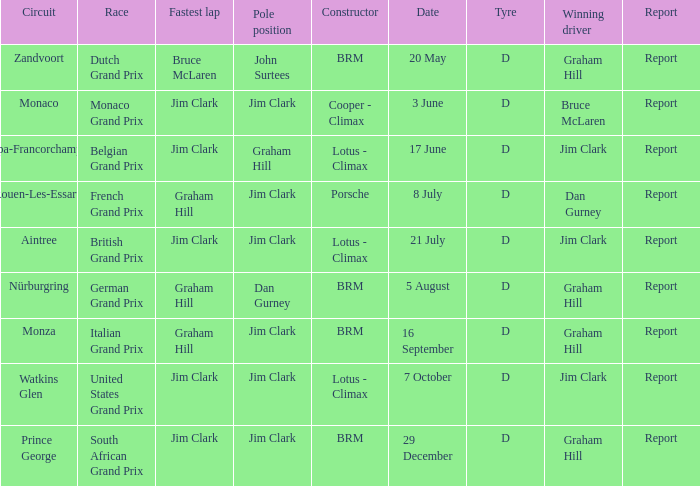What is the date of the circuit of Monaco? 3 June. 